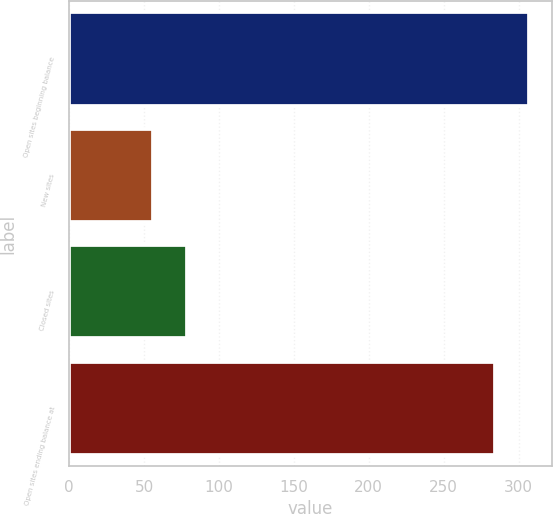Convert chart. <chart><loc_0><loc_0><loc_500><loc_500><bar_chart><fcel>Open sites beginning balance<fcel>New sites<fcel>Closed sites<fcel>Open sites ending balance at<nl><fcel>306.9<fcel>56<fcel>78.9<fcel>284<nl></chart> 